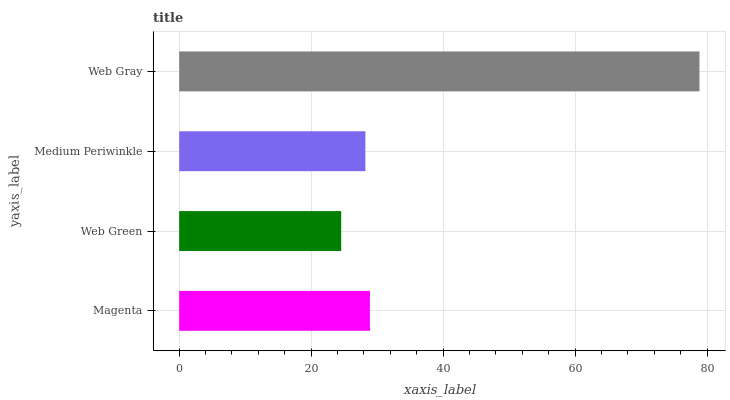Is Web Green the minimum?
Answer yes or no. Yes. Is Web Gray the maximum?
Answer yes or no. Yes. Is Medium Periwinkle the minimum?
Answer yes or no. No. Is Medium Periwinkle the maximum?
Answer yes or no. No. Is Medium Periwinkle greater than Web Green?
Answer yes or no. Yes. Is Web Green less than Medium Periwinkle?
Answer yes or no. Yes. Is Web Green greater than Medium Periwinkle?
Answer yes or no. No. Is Medium Periwinkle less than Web Green?
Answer yes or no. No. Is Magenta the high median?
Answer yes or no. Yes. Is Medium Periwinkle the low median?
Answer yes or no. Yes. Is Web Green the high median?
Answer yes or no. No. Is Web Gray the low median?
Answer yes or no. No. 